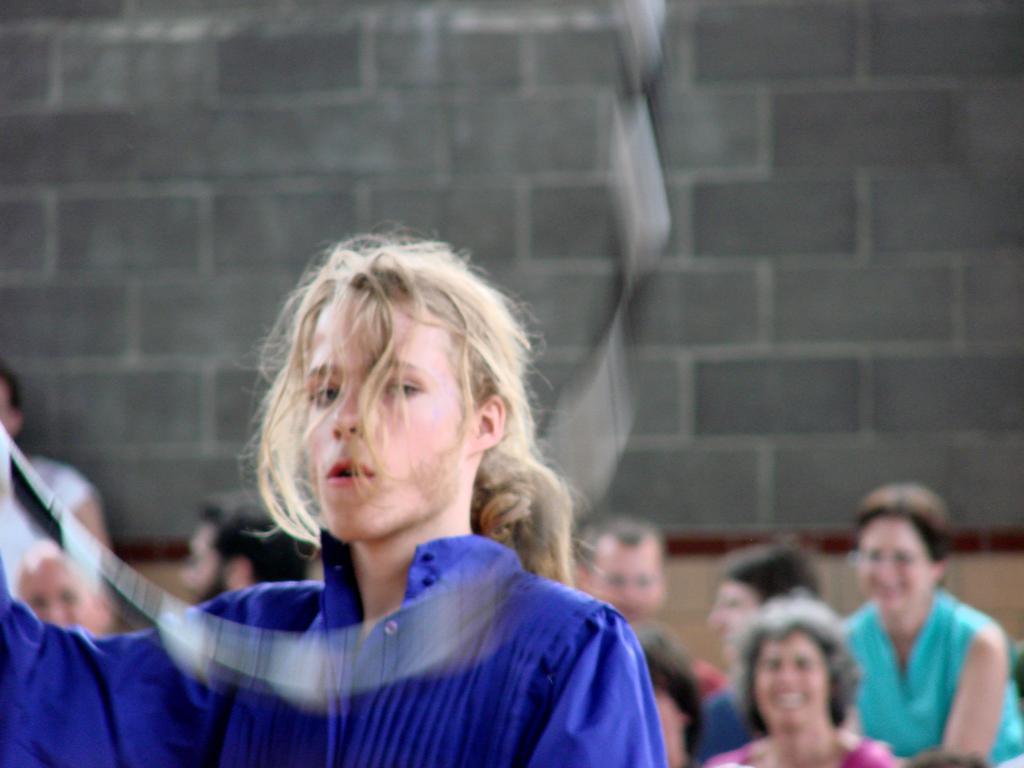Please provide a concise description of this image. In this image we can see people. Background it is blur. We can see a wall. 